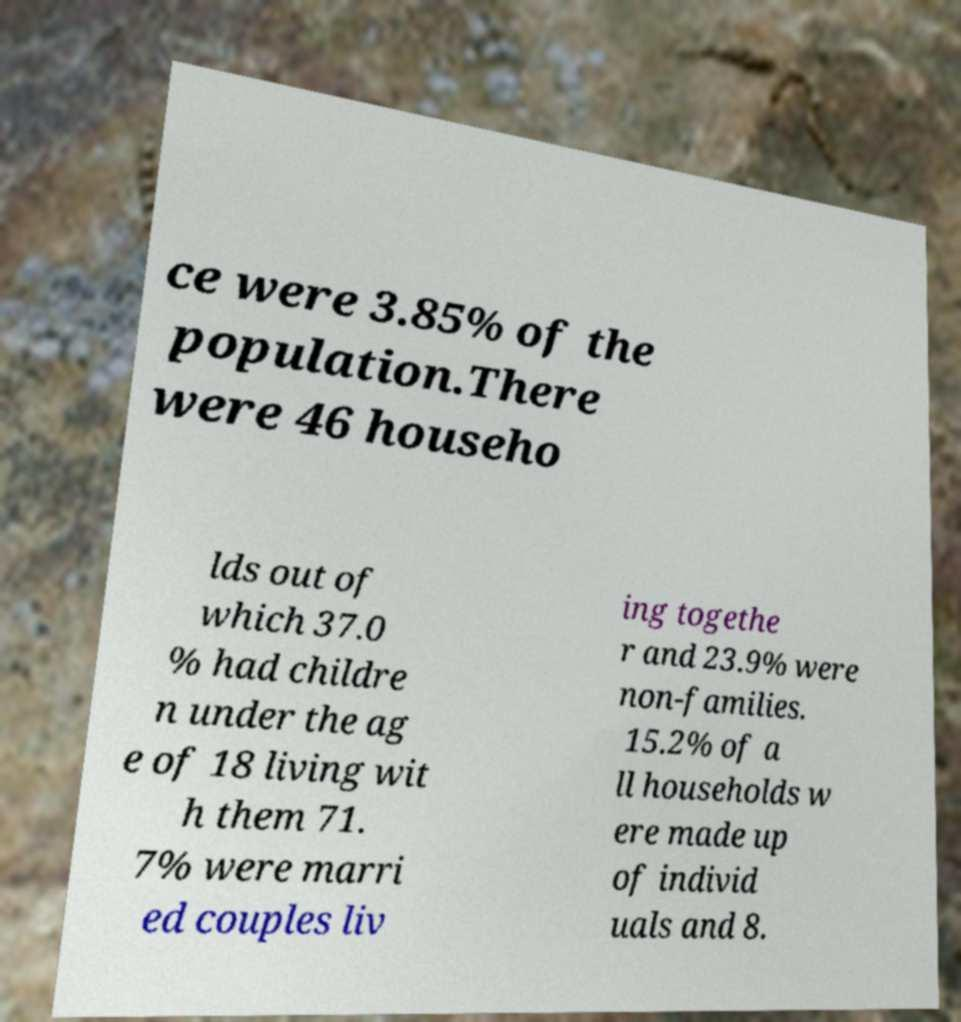For documentation purposes, I need the text within this image transcribed. Could you provide that? ce were 3.85% of the population.There were 46 househo lds out of which 37.0 % had childre n under the ag e of 18 living wit h them 71. 7% were marri ed couples liv ing togethe r and 23.9% were non-families. 15.2% of a ll households w ere made up of individ uals and 8. 